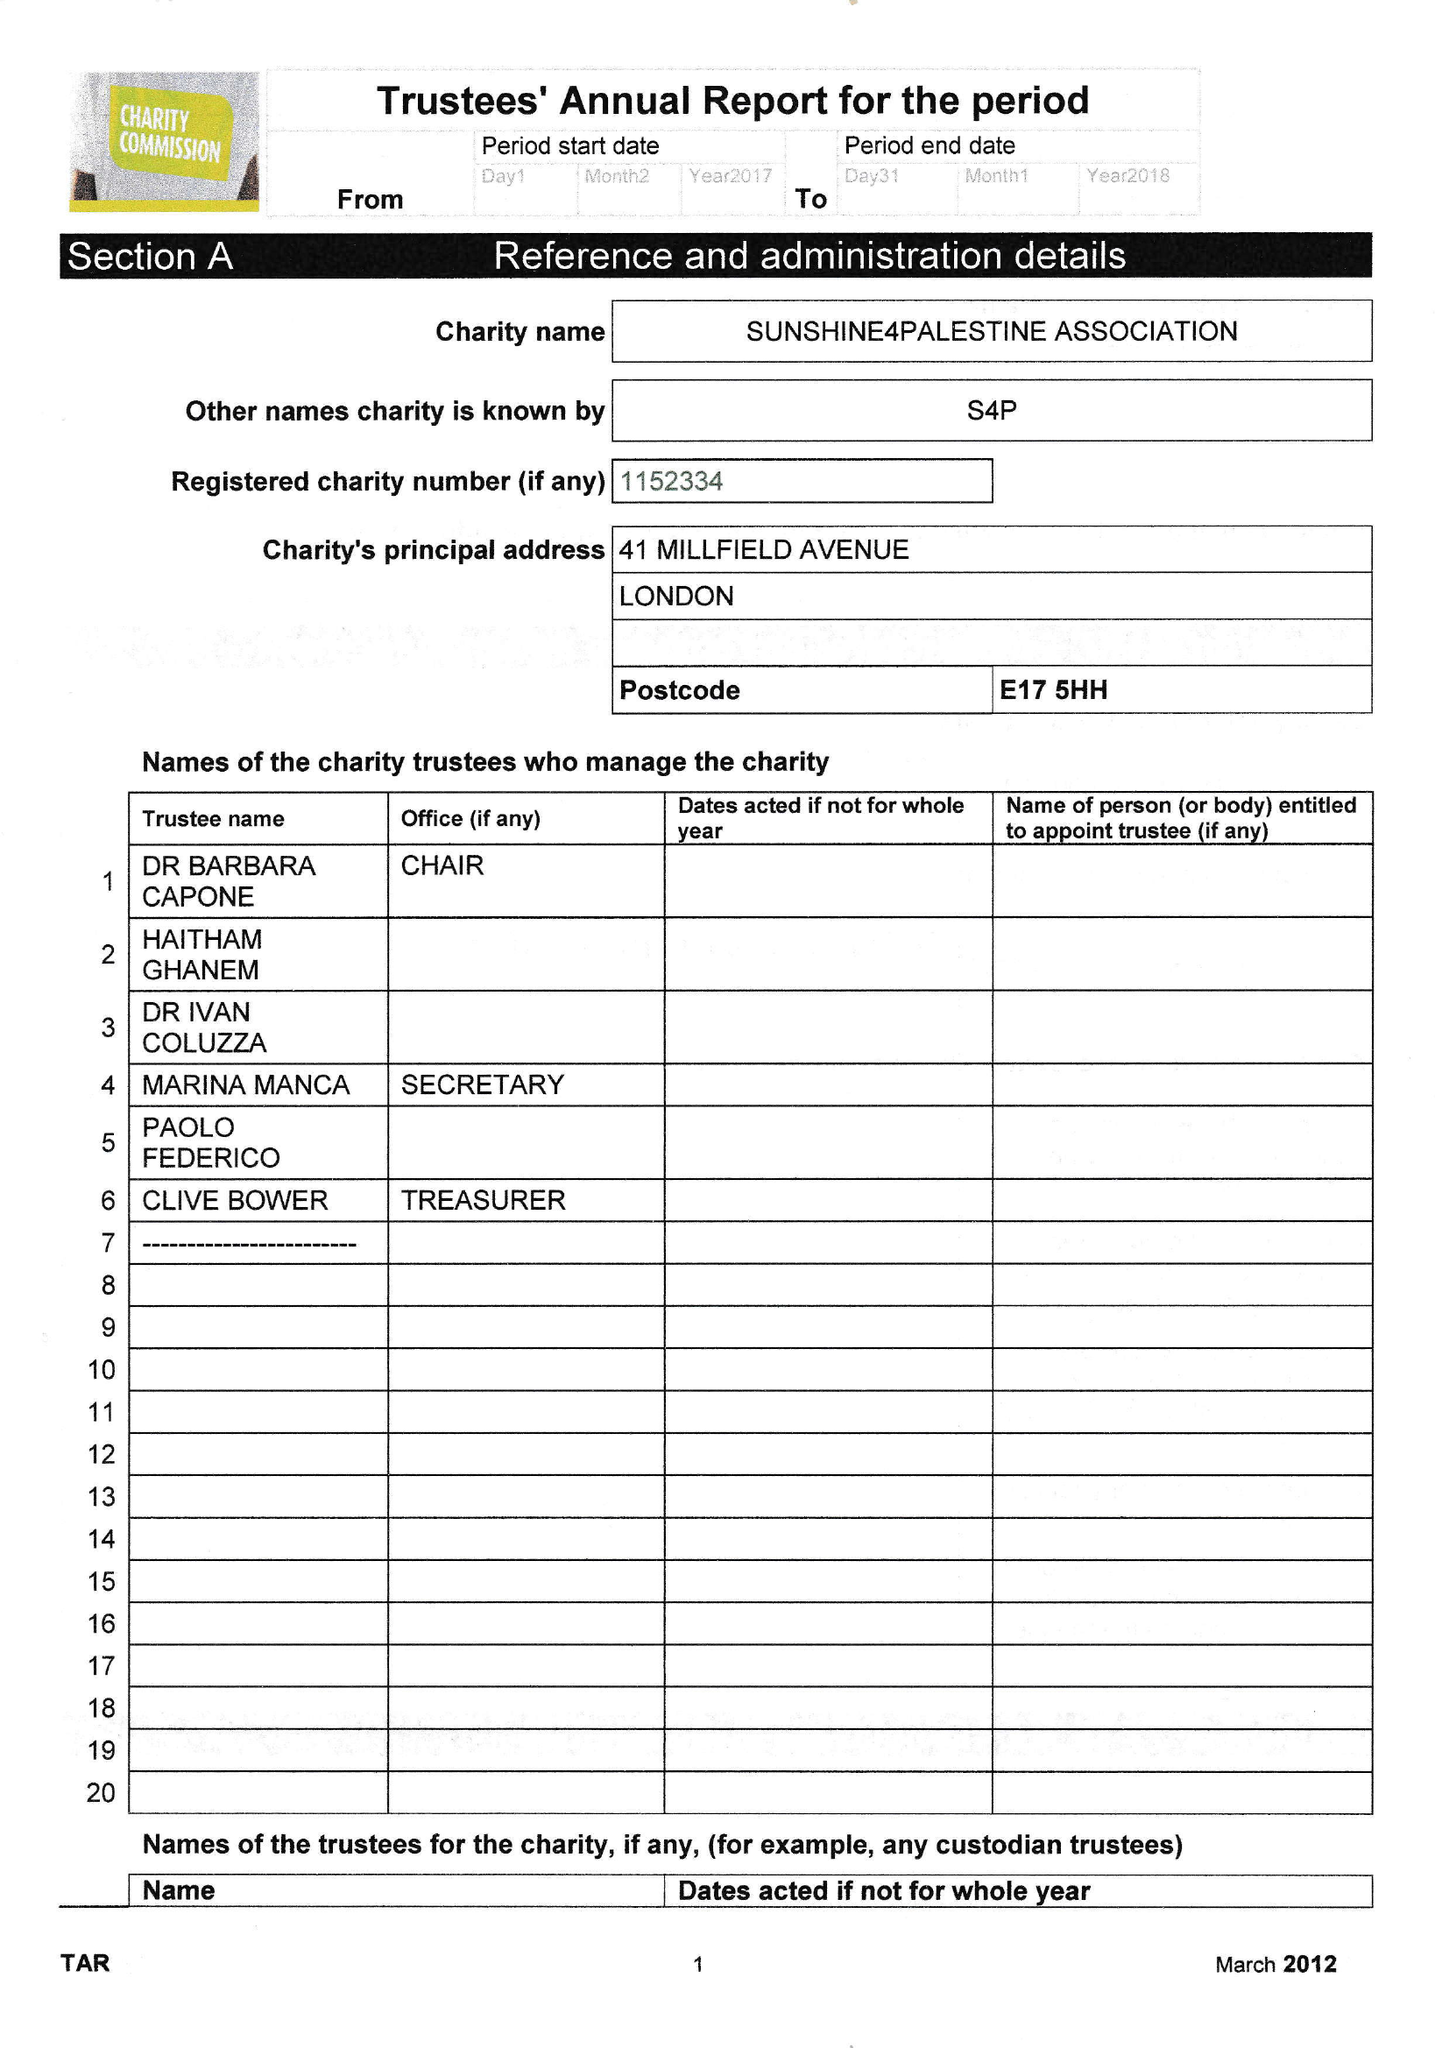What is the value for the charity_number?
Answer the question using a single word or phrase. 1152334 